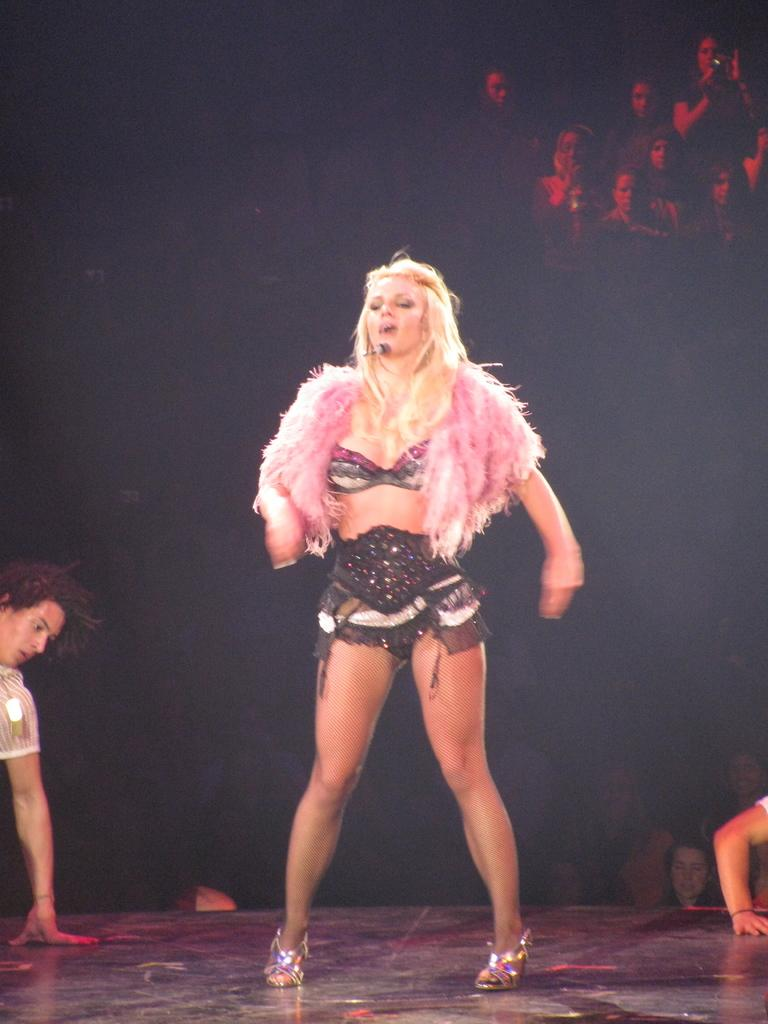What is the main subject of the image? There is a person standing in the image. What is the person wearing? The person is wearing a black and pink dress. Can you describe the background of the image? There are people visible in the background of the image. What type of pail can be seen in the person's hand in the image? There is no pail visible in the person's hand or anywhere else in the image. 